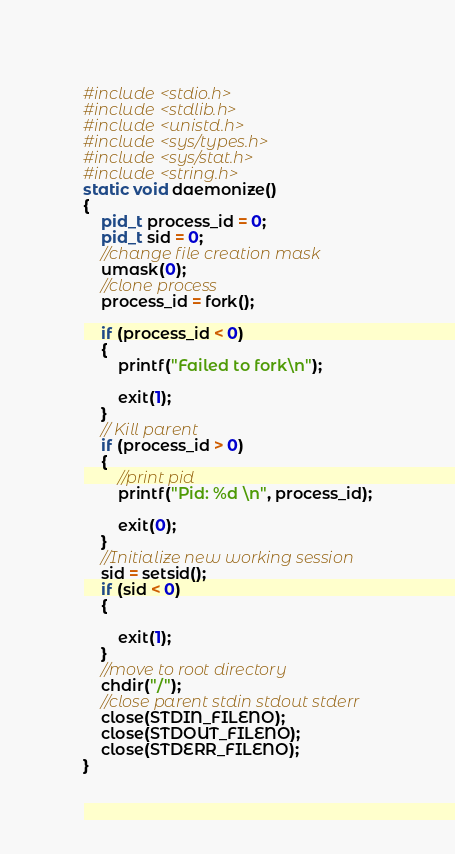Convert code to text. <code><loc_0><loc_0><loc_500><loc_500><_C_>#include <stdio.h>
#include <stdlib.h>
#include <unistd.h>
#include <sys/types.h>
#include <sys/stat.h>
#include <string.h>
static void daemonize()
{
    pid_t process_id = 0;
    pid_t sid = 0;
    //change file creation mask
    umask(0);
    //clone process
    process_id = fork();
    
    if (process_id < 0)
    {
        printf("Failed to fork\n");
        
        exit(1);
    }
    // Kill parent
    if (process_id > 0)
    {
        //print pid
        printf("Pid: %d \n", process_id);
        
        exit(0);
    }
    //Initialize new working session 
    sid = setsid();
    if (sid < 0)
    {
        
        exit(1);
    }
    //move to root directory
    chdir("/");
    //close parent stdin stdout stderr
    close(STDIN_FILENO);
    close(STDOUT_FILENO);
    close(STDERR_FILENO);
}</code> 